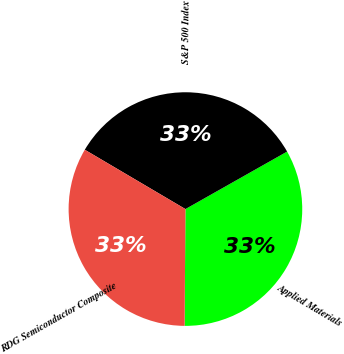<chart> <loc_0><loc_0><loc_500><loc_500><pie_chart><fcel>Applied Materials<fcel>S&P 500 Index<fcel>RDG Semiconductor Composite<nl><fcel>33.3%<fcel>33.33%<fcel>33.37%<nl></chart> 